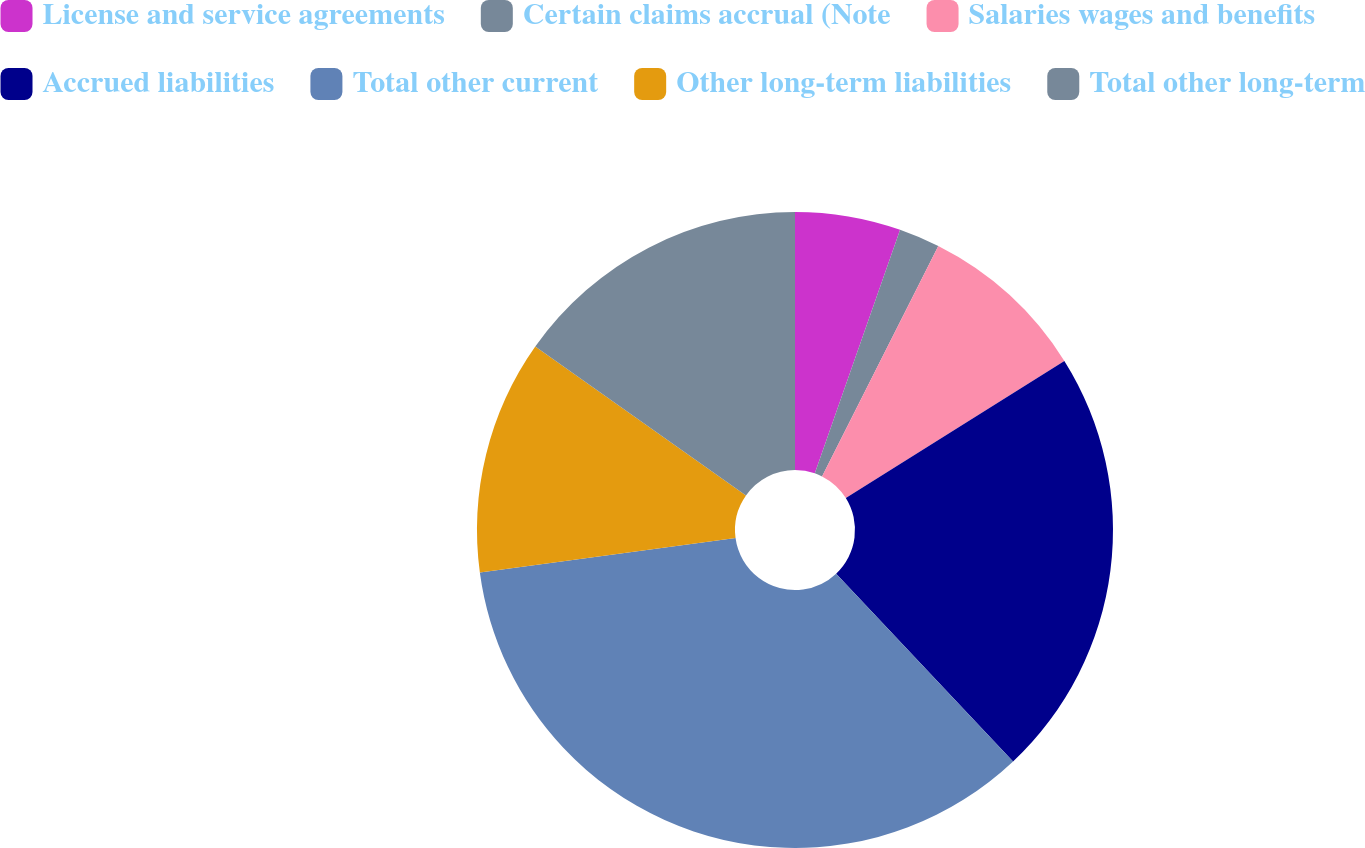Convert chart to OTSL. <chart><loc_0><loc_0><loc_500><loc_500><pie_chart><fcel>License and service agreements<fcel>Certain claims accrual (Note<fcel>Salaries wages and benefits<fcel>Accrued liabilities<fcel>Total other current<fcel>Other long-term liabilities<fcel>Total other long-term<nl><fcel>5.36%<fcel>2.08%<fcel>8.64%<fcel>21.89%<fcel>34.89%<fcel>11.92%<fcel>15.21%<nl></chart> 